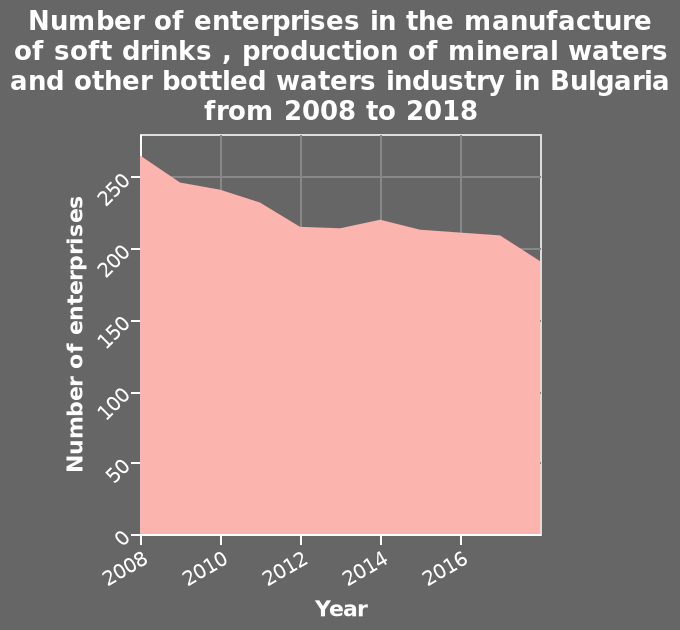<image>
Offer a thorough analysis of the image. The number of enterprises manufacturing soft drinks decreases with time. What type of plot is used to represent the data? The data is represented using an area plot. 